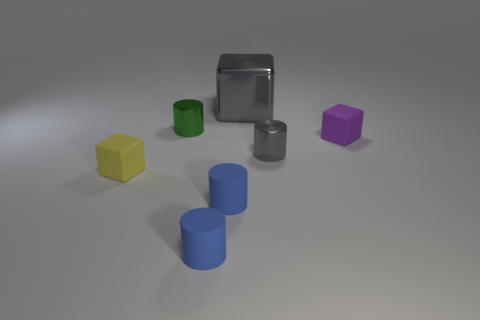What is the thing that is both behind the small purple matte block and to the right of the green cylinder made of?
Offer a very short reply. Metal. Do the small matte block that is on the right side of the small yellow thing and the big thing have the same color?
Your answer should be compact. No. Is the color of the big metallic object the same as the cube that is on the right side of the gray cylinder?
Your answer should be compact. No. Are there any large things behind the big gray shiny block?
Keep it short and to the point. No. Are the big gray object and the purple cube made of the same material?
Provide a succinct answer. No. What material is the gray cylinder that is the same size as the purple thing?
Offer a very short reply. Metal. How many things are cubes in front of the tiny green thing or cyan balls?
Offer a terse response. 2. Is the number of purple rubber objects behind the large gray shiny block the same as the number of small gray metallic objects?
Ensure brevity in your answer.  No. What is the color of the small object that is both behind the small yellow cube and in front of the purple object?
Make the answer very short. Gray. How many spheres are either big things or small gray metallic things?
Offer a terse response. 0. 